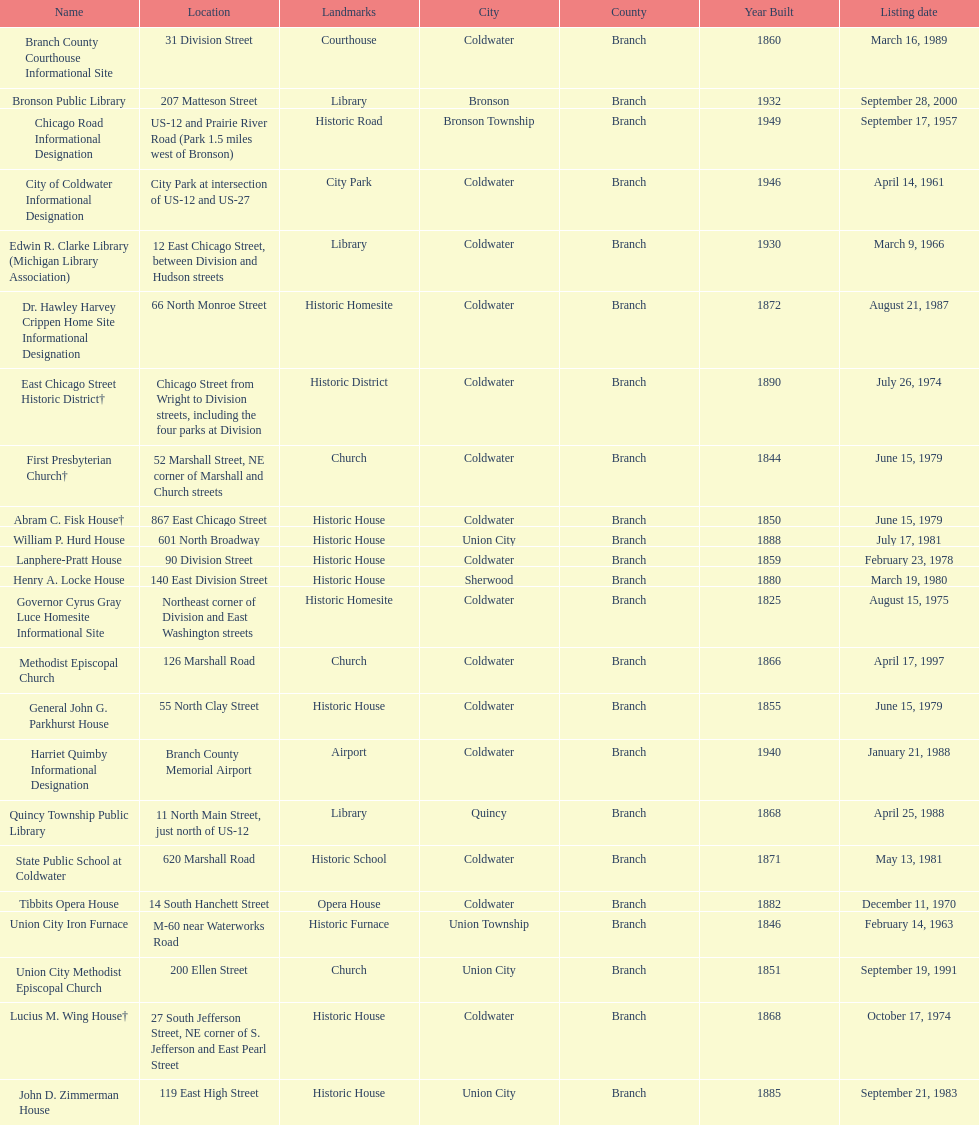How many sites are in coldwater? 15. 